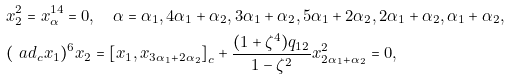Convert formula to latex. <formula><loc_0><loc_0><loc_500><loc_500>& x _ { 2 } ^ { 2 } = x _ { \alpha } ^ { 1 4 } = 0 , \quad \alpha = \alpha _ { 1 } , 4 \alpha _ { 1 } + \alpha _ { 2 } , 3 \alpha _ { 1 } + \alpha _ { 2 } , 5 \alpha _ { 1 } + 2 \alpha _ { 2 } , 2 \alpha _ { 1 } + \alpha _ { 2 } , \alpha _ { 1 } + \alpha _ { 2 } , \\ & ( \ a d _ { c } x _ { 1 } ) ^ { 6 } x _ { 2 } = \left [ x _ { 1 } , x _ { 3 \alpha _ { 1 } + 2 \alpha _ { 2 } } \right ] _ { c } + \frac { ( 1 + \zeta ^ { 4 } ) q _ { 1 2 } } { 1 - \zeta ^ { 2 } } x _ { 2 \alpha _ { 1 } + \alpha _ { 2 } } ^ { 2 } = 0 ,</formula> 